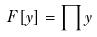Convert formula to latex. <formula><loc_0><loc_0><loc_500><loc_500>F [ y ] = \prod y</formula> 